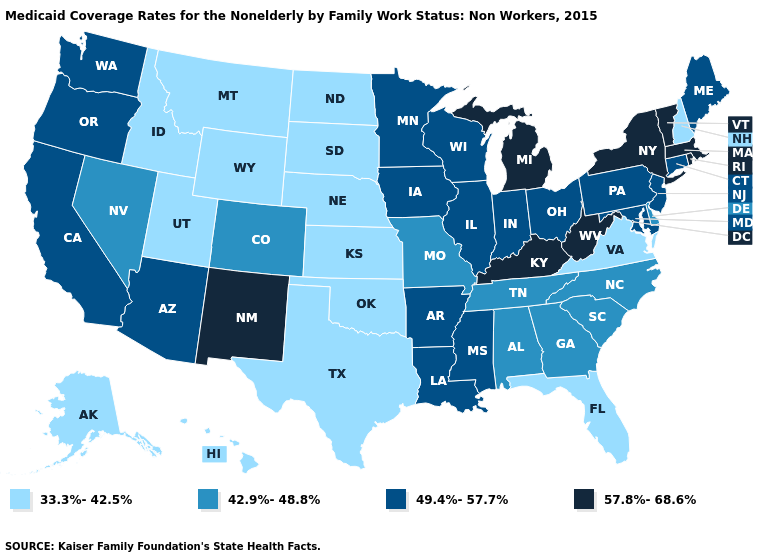Among the states that border Pennsylvania , which have the lowest value?
Write a very short answer. Delaware. Does New Hampshire have the same value as Virginia?
Give a very brief answer. Yes. Which states hav the highest value in the MidWest?
Quick response, please. Michigan. Does Hawaii have the lowest value in the West?
Quick response, please. Yes. Name the states that have a value in the range 57.8%-68.6%?
Give a very brief answer. Kentucky, Massachusetts, Michigan, New Mexico, New York, Rhode Island, Vermont, West Virginia. Name the states that have a value in the range 42.9%-48.8%?
Give a very brief answer. Alabama, Colorado, Delaware, Georgia, Missouri, Nevada, North Carolina, South Carolina, Tennessee. Does the map have missing data?
Write a very short answer. No. Which states have the lowest value in the USA?
Give a very brief answer. Alaska, Florida, Hawaii, Idaho, Kansas, Montana, Nebraska, New Hampshire, North Dakota, Oklahoma, South Dakota, Texas, Utah, Virginia, Wyoming. What is the value of Montana?
Quick response, please. 33.3%-42.5%. Among the states that border South Dakota , which have the lowest value?
Concise answer only. Montana, Nebraska, North Dakota, Wyoming. Does Texas have the lowest value in the USA?
Be succinct. Yes. What is the highest value in states that border Oregon?
Concise answer only. 49.4%-57.7%. What is the value of Idaho?
Concise answer only. 33.3%-42.5%. Name the states that have a value in the range 57.8%-68.6%?
Concise answer only. Kentucky, Massachusetts, Michigan, New Mexico, New York, Rhode Island, Vermont, West Virginia. 